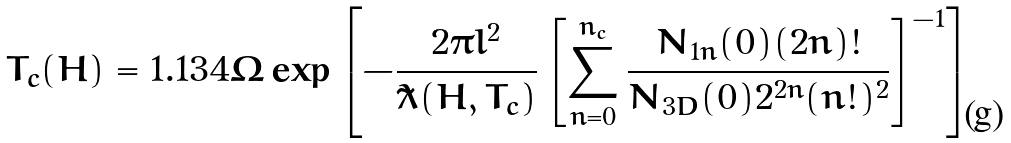Convert formula to latex. <formula><loc_0><loc_0><loc_500><loc_500>T _ { c } ( H ) = 1 . 1 3 4 \Omega \exp { \left [ - \frac { 2 \pi l ^ { 2 } } { \tilde { \lambda } ( H , T _ { c } ) } \left [ \sum _ { n = 0 } ^ { n _ { c } } \frac { N _ { 1 n } ( 0 ) ( 2 n ) ! } { N _ { 3 D } ( 0 ) 2 ^ { 2 n } ( n ! ) ^ { 2 } } \right ] ^ { - 1 } \right ] }</formula> 